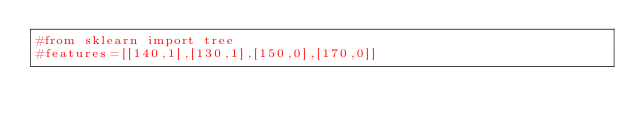<code> <loc_0><loc_0><loc_500><loc_500><_Python_>#from sklearn import tree
#features=[[140,1],[130,1],[150,0],[170,0]]</code> 